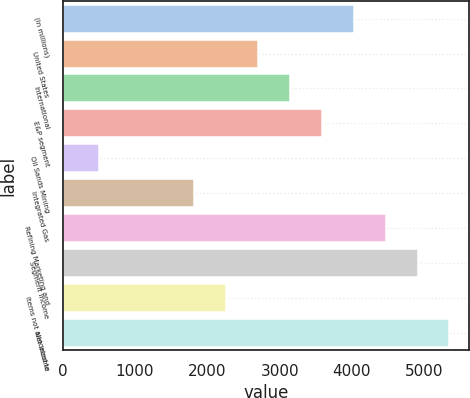Convert chart to OTSL. <chart><loc_0><loc_0><loc_500><loc_500><bar_chart><fcel>(In millions)<fcel>United States<fcel>International<fcel>E&P segment<fcel>Oil Sands Mining<fcel>Integrated Gas<fcel>Refining Marketing and<fcel>Segment income<fcel>Items not allocated to<fcel>Net income<nl><fcel>4025.1<fcel>2702.4<fcel>3143.3<fcel>3584.2<fcel>497.9<fcel>1820.6<fcel>4466<fcel>4906.9<fcel>2261.5<fcel>5347.8<nl></chart> 